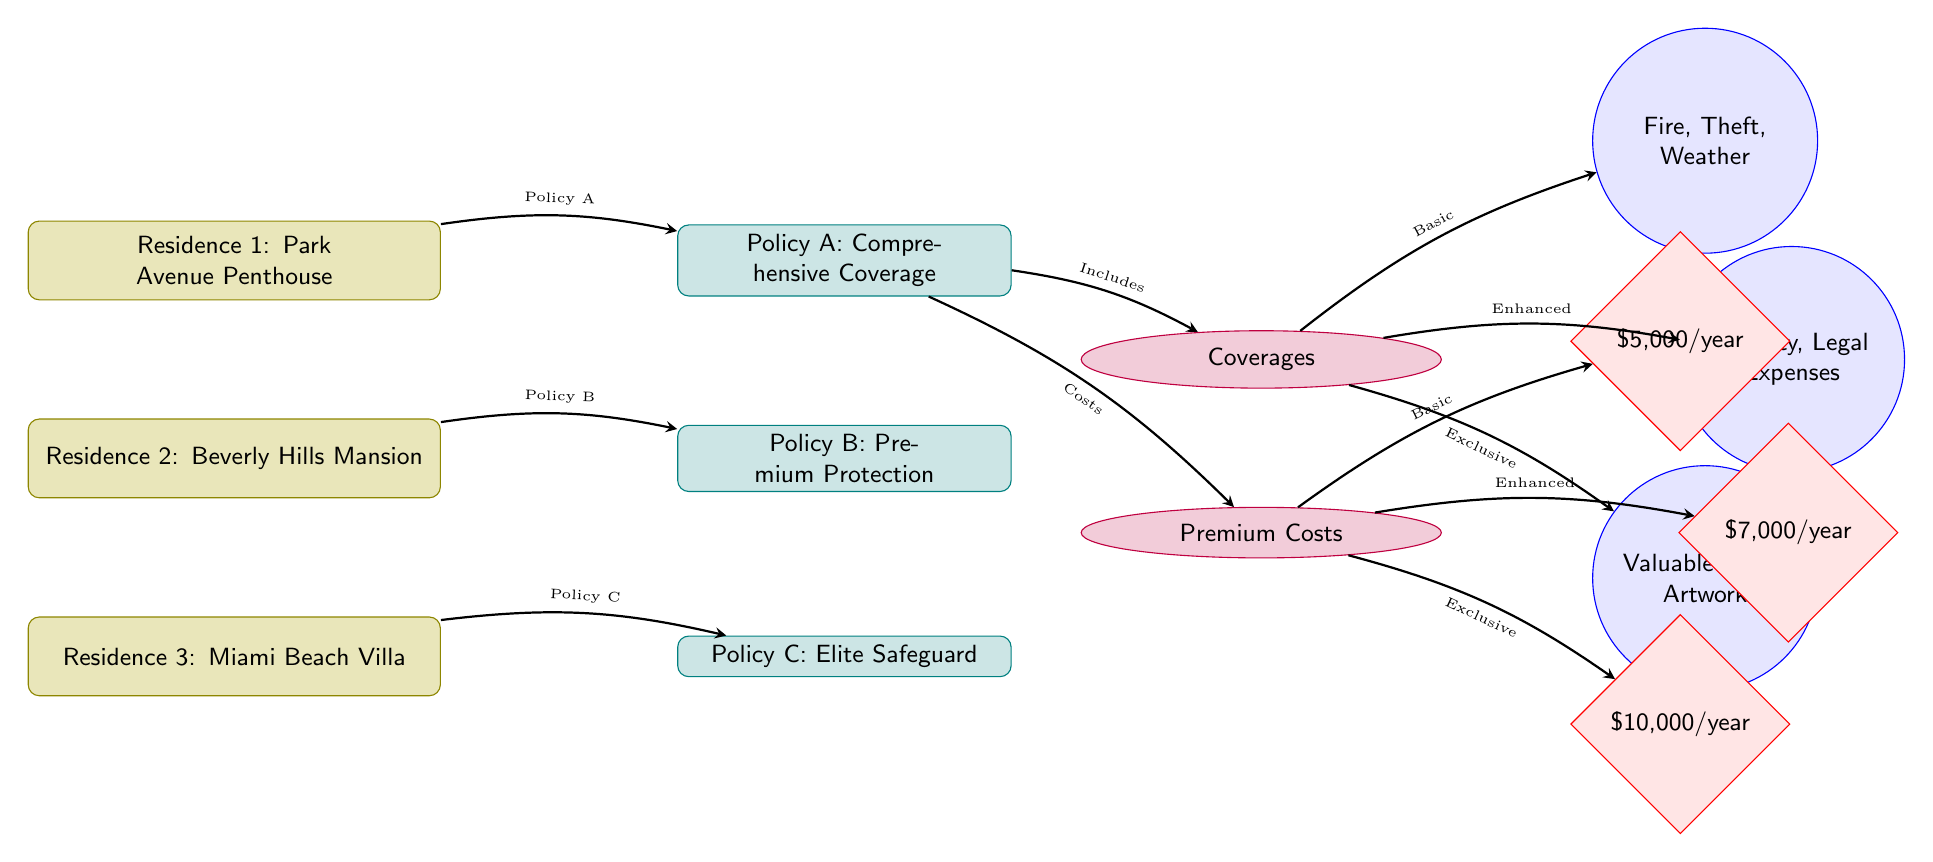What is the annual premium for Policy A? The diagram indicates that the annual premium for Policy A is stated directly within the diamond-shaped node connected to Policy A. Reading the label in that node shows it is \$5,000/year.
Answer: \$5,000/year Which residence corresponds to Policy B? By tracing the diagram, Policy B is connected to Residence 2 through an edge labeled "Policy B." The specific node for Residence 2 identifies it as the Beverly Hills Mansion.
Answer: Beverly Hills Mansion How many coverage types are associated with Policy A? The diagram shows that Policy A has a connection to the section labeled 'Coverages.' Below that section, there are three circular nodes connected, indicating three coverage types (Fire, Theft, Weather). Therefore, Policy A is associated with three coverage types.
Answer: 3 What are the included coverages for Policy C? For Policy C, the diagram has an edge leading to the 'Coverages' section, and from there, it connects to a specific coverage node labeled with 'Valuable Items, Artwork' and no other items. So, the included coverages for Policy C are only those listed in that node.
Answer: Valuable Items, Artwork Which residence has the highest premium cost? Examining the 'Premium Costs' section, we note that Policy C, corresponding to Residence 3 (Miami Beach Villa), has the highest annual premium at \$10,000/year. This can be determined by comparing the premium amounts shown for each policy.
Answer: \$10,000/year 